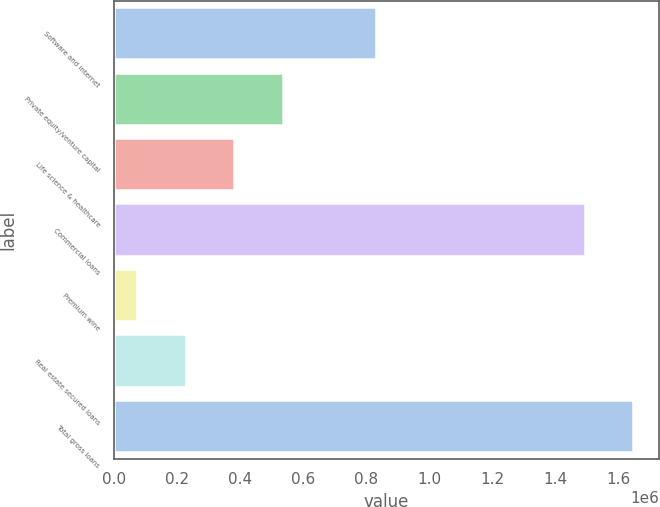Convert chart to OTSL. <chart><loc_0><loc_0><loc_500><loc_500><bar_chart><fcel>Software and internet<fcel>Private equity/venture capital<fcel>Life science & healthcare<fcel>Commercial loans<fcel>Premium wine<fcel>Real estate secured loans<fcel>Total gross loans<nl><fcel>832375<fcel>535423<fcel>381480<fcel>1.4929e+06<fcel>73594<fcel>227537<fcel>1.64684e+06<nl></chart> 